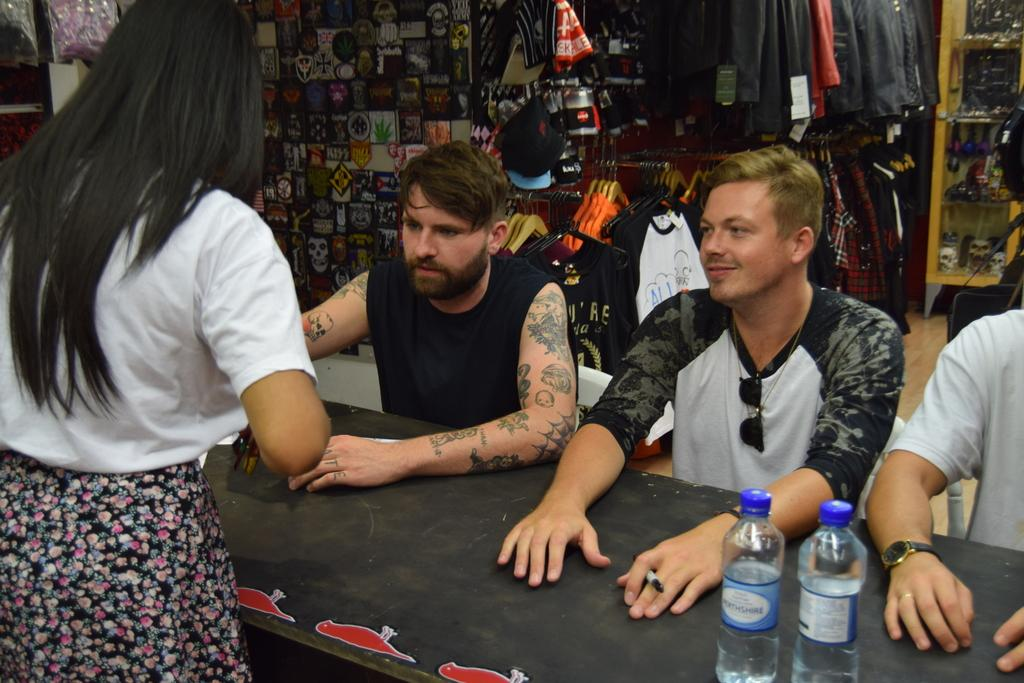Who or what can be seen in the image? There are people in the image. What objects are present on the table in the image? There are bottles on a table. What can be seen in the background of the image? There are clothes and other things visible in the background. Can you describe any specific features of the people in the image? At least one person in the image has tattoos on their hands. How many kittens are playing in the store in the image? There are no kittens or stores present in the image. Can you describe the effect of the wind on the people in the image? There is no mention of wind in the image, so we cannot describe its effect on the people. 